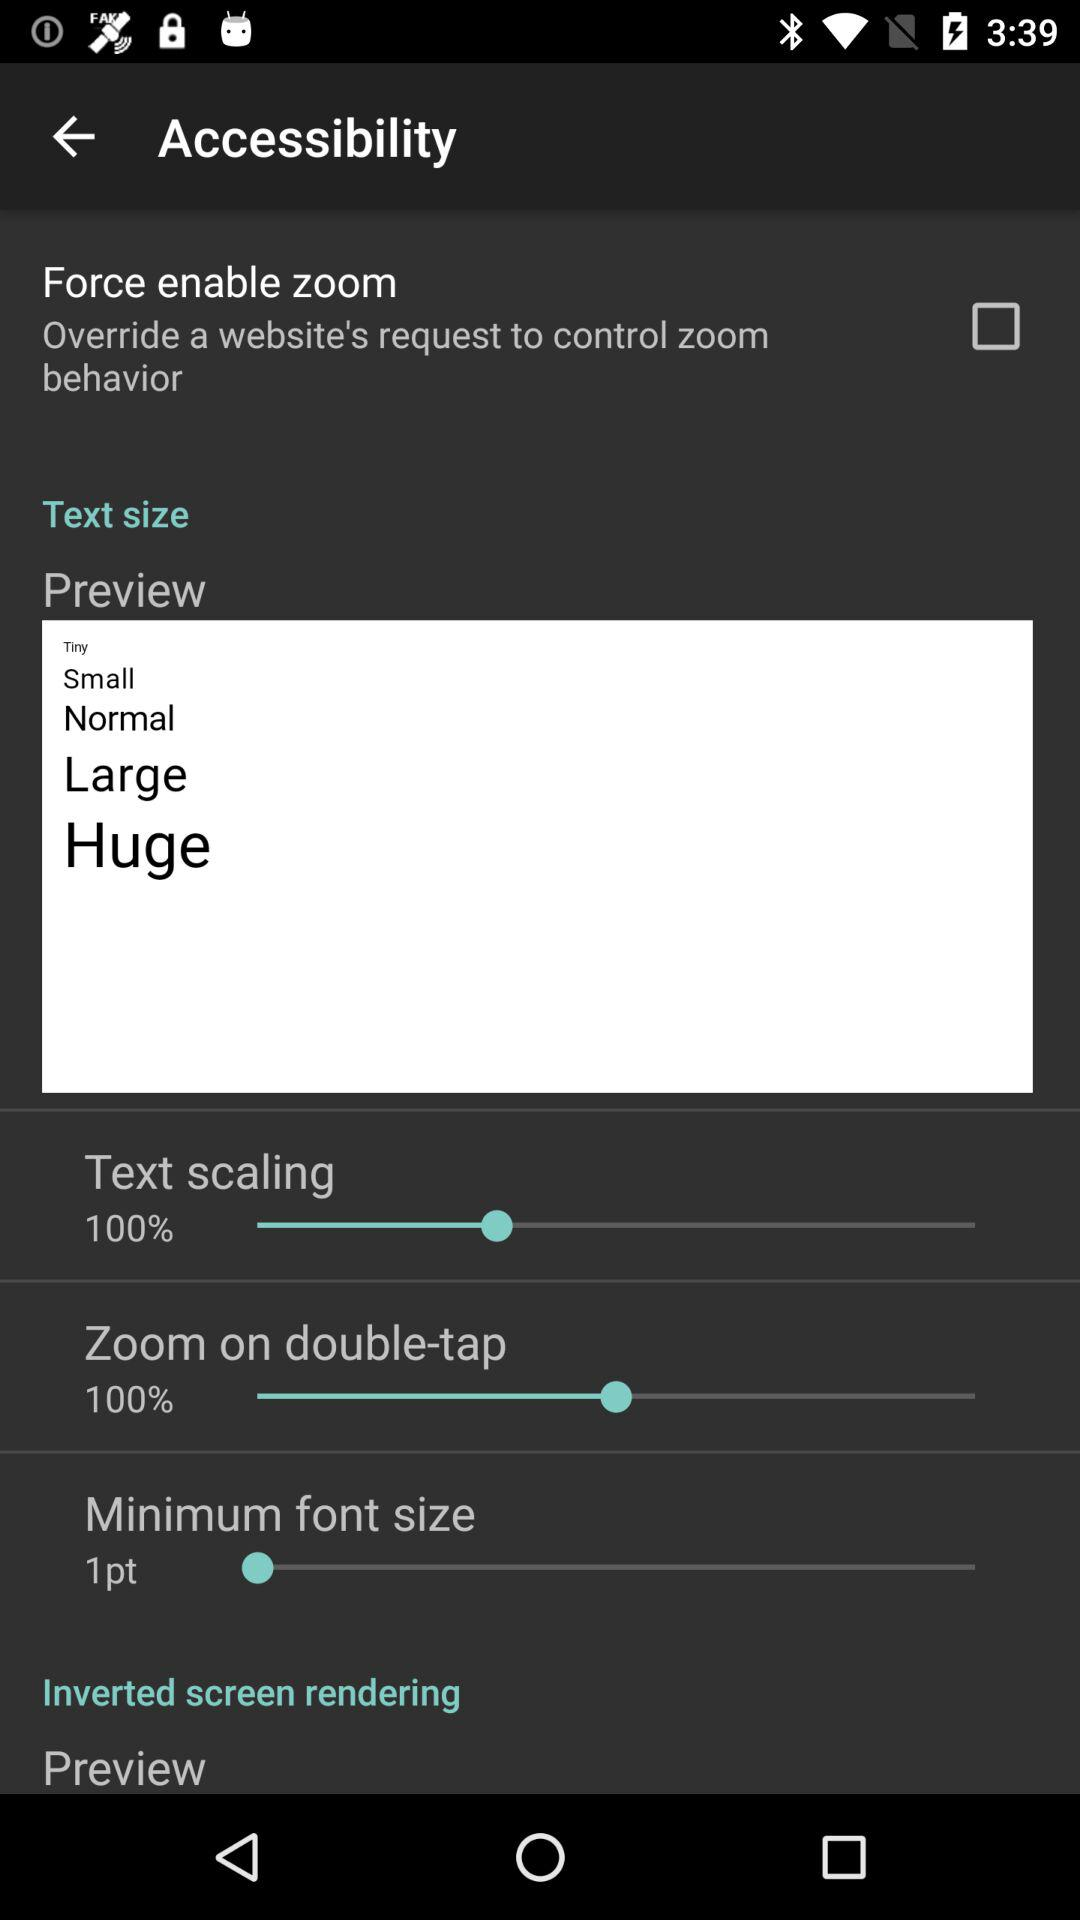What is the percentage of "Zoom on double-tap"? The percentage of "Zoom on double-tap" is 100%. 